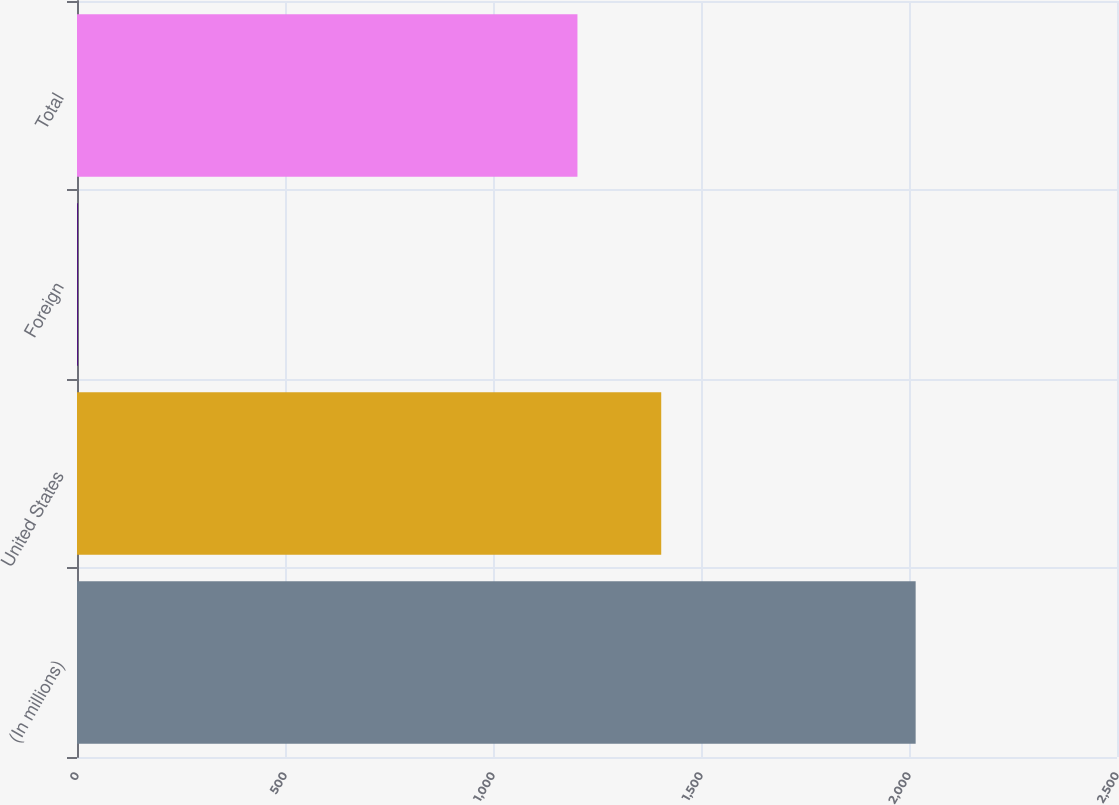<chart> <loc_0><loc_0><loc_500><loc_500><bar_chart><fcel>(In millions)<fcel>United States<fcel>Foreign<fcel>Total<nl><fcel>2016<fcel>1404.4<fcel>2<fcel>1203<nl></chart> 